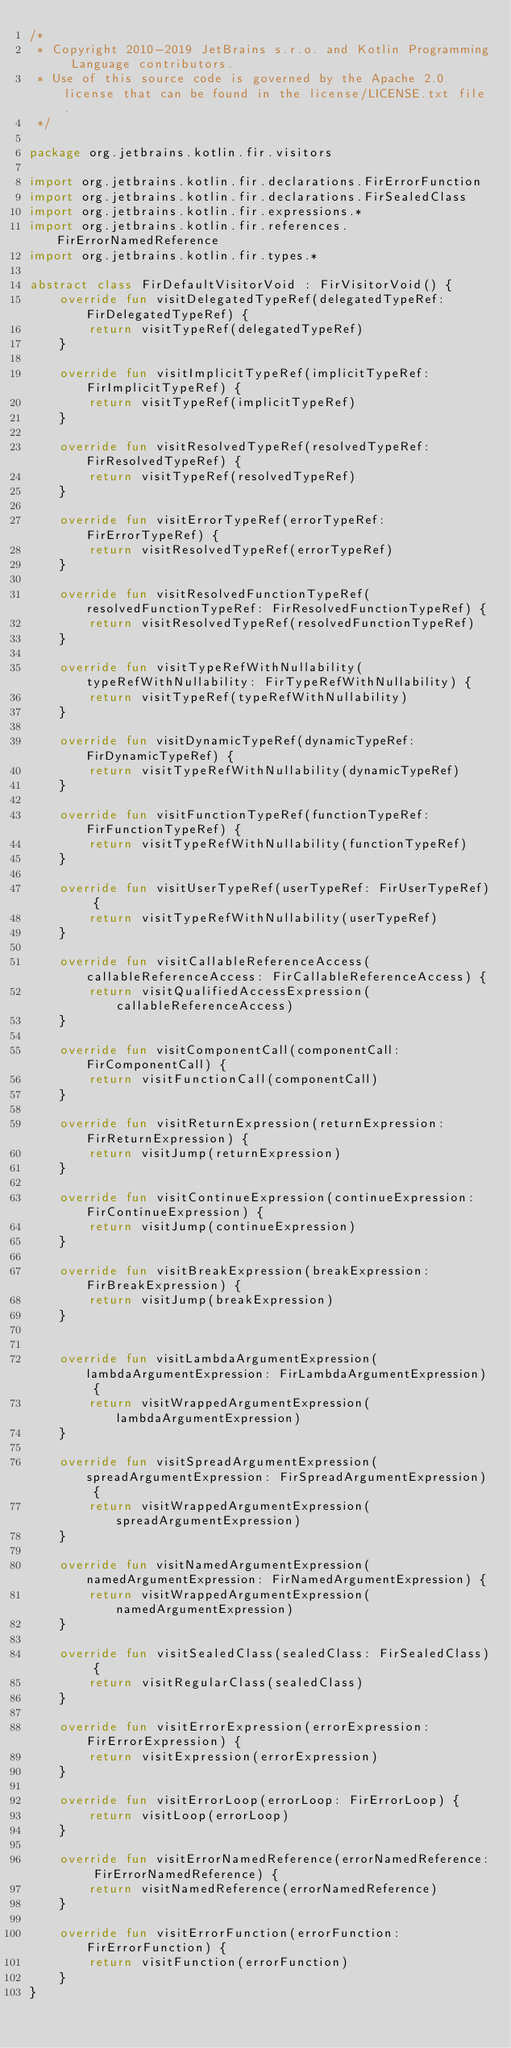Convert code to text. <code><loc_0><loc_0><loc_500><loc_500><_Kotlin_>/*
 * Copyright 2010-2019 JetBrains s.r.o. and Kotlin Programming Language contributors.
 * Use of this source code is governed by the Apache 2.0 license that can be found in the license/LICENSE.txt file.
 */

package org.jetbrains.kotlin.fir.visitors

import org.jetbrains.kotlin.fir.declarations.FirErrorFunction
import org.jetbrains.kotlin.fir.declarations.FirSealedClass
import org.jetbrains.kotlin.fir.expressions.*
import org.jetbrains.kotlin.fir.references.FirErrorNamedReference
import org.jetbrains.kotlin.fir.types.*

abstract class FirDefaultVisitorVoid : FirVisitorVoid() {
    override fun visitDelegatedTypeRef(delegatedTypeRef: FirDelegatedTypeRef) {
        return visitTypeRef(delegatedTypeRef)
    }

    override fun visitImplicitTypeRef(implicitTypeRef: FirImplicitTypeRef) {
        return visitTypeRef(implicitTypeRef)
    }

    override fun visitResolvedTypeRef(resolvedTypeRef: FirResolvedTypeRef) {
        return visitTypeRef(resolvedTypeRef)
    }

    override fun visitErrorTypeRef(errorTypeRef: FirErrorTypeRef) {
        return visitResolvedTypeRef(errorTypeRef)
    }

    override fun visitResolvedFunctionTypeRef(resolvedFunctionTypeRef: FirResolvedFunctionTypeRef) {
        return visitResolvedTypeRef(resolvedFunctionTypeRef)
    }

    override fun visitTypeRefWithNullability(typeRefWithNullability: FirTypeRefWithNullability) {
        return visitTypeRef(typeRefWithNullability)
    }

    override fun visitDynamicTypeRef(dynamicTypeRef: FirDynamicTypeRef) {
        return visitTypeRefWithNullability(dynamicTypeRef)
    }

    override fun visitFunctionTypeRef(functionTypeRef: FirFunctionTypeRef) {
        return visitTypeRefWithNullability(functionTypeRef)
    }

    override fun visitUserTypeRef(userTypeRef: FirUserTypeRef) {
        return visitTypeRefWithNullability(userTypeRef)
    }

    override fun visitCallableReferenceAccess(callableReferenceAccess: FirCallableReferenceAccess) {
        return visitQualifiedAccessExpression(callableReferenceAccess)
    }

    override fun visitComponentCall(componentCall: FirComponentCall) {
        return visitFunctionCall(componentCall)
    }

    override fun visitReturnExpression(returnExpression: FirReturnExpression) {
        return visitJump(returnExpression)
    }

    override fun visitContinueExpression(continueExpression: FirContinueExpression) {
        return visitJump(continueExpression)
    }

    override fun visitBreakExpression(breakExpression: FirBreakExpression) {
        return visitJump(breakExpression)
    }


    override fun visitLambdaArgumentExpression(lambdaArgumentExpression: FirLambdaArgumentExpression) {
        return visitWrappedArgumentExpression(lambdaArgumentExpression)
    }

    override fun visitSpreadArgumentExpression(spreadArgumentExpression: FirSpreadArgumentExpression) {
        return visitWrappedArgumentExpression(spreadArgumentExpression)
    }

    override fun visitNamedArgumentExpression(namedArgumentExpression: FirNamedArgumentExpression) {
        return visitWrappedArgumentExpression(namedArgumentExpression)
    }

    override fun visitSealedClass(sealedClass: FirSealedClass) {
        return visitRegularClass(sealedClass)
    }

    override fun visitErrorExpression(errorExpression: FirErrorExpression) {
        return visitExpression(errorExpression)
    }

    override fun visitErrorLoop(errorLoop: FirErrorLoop) {
        return visitLoop(errorLoop)
    }

    override fun visitErrorNamedReference(errorNamedReference: FirErrorNamedReference) {
        return visitNamedReference(errorNamedReference)
    }

    override fun visitErrorFunction(errorFunction: FirErrorFunction) {
        return visitFunction(errorFunction)
    }
}</code> 